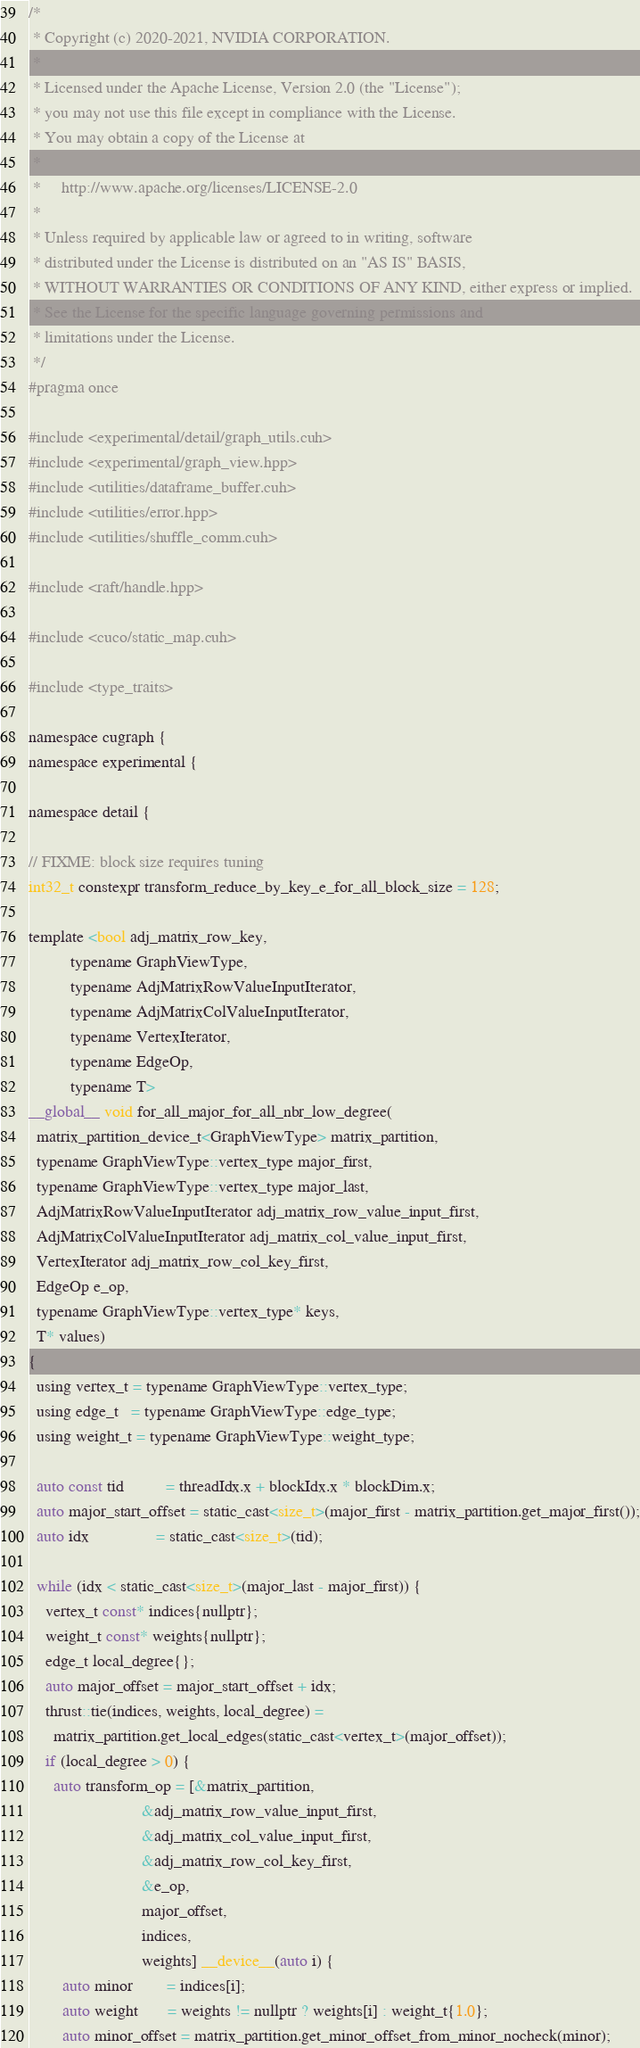<code> <loc_0><loc_0><loc_500><loc_500><_Cuda_>/*
 * Copyright (c) 2020-2021, NVIDIA CORPORATION.
 *
 * Licensed under the Apache License, Version 2.0 (the "License");
 * you may not use this file except in compliance with the License.
 * You may obtain a copy of the License at
 *
 *     http://www.apache.org/licenses/LICENSE-2.0
 *
 * Unless required by applicable law or agreed to in writing, software
 * distributed under the License is distributed on an "AS IS" BASIS,
 * WITHOUT WARRANTIES OR CONDITIONS OF ANY KIND, either express or implied.
 * See the License for the specific language governing permissions and
 * limitations under the License.
 */
#pragma once

#include <experimental/detail/graph_utils.cuh>
#include <experimental/graph_view.hpp>
#include <utilities/dataframe_buffer.cuh>
#include <utilities/error.hpp>
#include <utilities/shuffle_comm.cuh>

#include <raft/handle.hpp>

#include <cuco/static_map.cuh>

#include <type_traits>

namespace cugraph {
namespace experimental {

namespace detail {

// FIXME: block size requires tuning
int32_t constexpr transform_reduce_by_key_e_for_all_block_size = 128;

template <bool adj_matrix_row_key,
          typename GraphViewType,
          typename AdjMatrixRowValueInputIterator,
          typename AdjMatrixColValueInputIterator,
          typename VertexIterator,
          typename EdgeOp,
          typename T>
__global__ void for_all_major_for_all_nbr_low_degree(
  matrix_partition_device_t<GraphViewType> matrix_partition,
  typename GraphViewType::vertex_type major_first,
  typename GraphViewType::vertex_type major_last,
  AdjMatrixRowValueInputIterator adj_matrix_row_value_input_first,
  AdjMatrixColValueInputIterator adj_matrix_col_value_input_first,
  VertexIterator adj_matrix_row_col_key_first,
  EdgeOp e_op,
  typename GraphViewType::vertex_type* keys,
  T* values)
{
  using vertex_t = typename GraphViewType::vertex_type;
  using edge_t   = typename GraphViewType::edge_type;
  using weight_t = typename GraphViewType::weight_type;

  auto const tid          = threadIdx.x + blockIdx.x * blockDim.x;
  auto major_start_offset = static_cast<size_t>(major_first - matrix_partition.get_major_first());
  auto idx                = static_cast<size_t>(tid);

  while (idx < static_cast<size_t>(major_last - major_first)) {
    vertex_t const* indices{nullptr};
    weight_t const* weights{nullptr};
    edge_t local_degree{};
    auto major_offset = major_start_offset + idx;
    thrust::tie(indices, weights, local_degree) =
      matrix_partition.get_local_edges(static_cast<vertex_t>(major_offset));
    if (local_degree > 0) {
      auto transform_op = [&matrix_partition,
                           &adj_matrix_row_value_input_first,
                           &adj_matrix_col_value_input_first,
                           &adj_matrix_row_col_key_first,
                           &e_op,
                           major_offset,
                           indices,
                           weights] __device__(auto i) {
        auto minor        = indices[i];
        auto weight       = weights != nullptr ? weights[i] : weight_t{1.0};
        auto minor_offset = matrix_partition.get_minor_offset_from_minor_nocheck(minor);</code> 